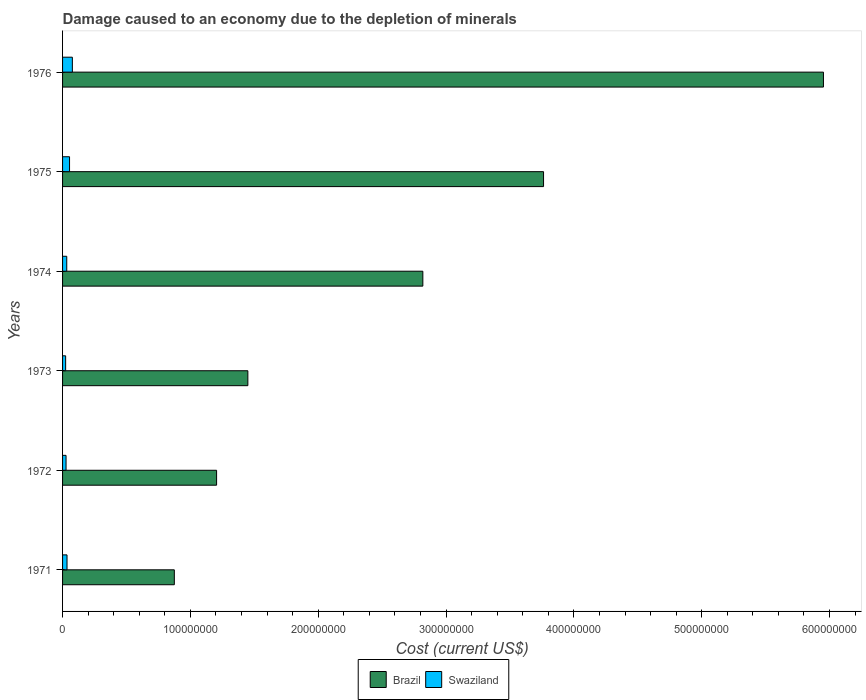How many different coloured bars are there?
Give a very brief answer. 2. Are the number of bars per tick equal to the number of legend labels?
Provide a succinct answer. Yes. What is the label of the 5th group of bars from the top?
Your response must be concise. 1972. In how many cases, is the number of bars for a given year not equal to the number of legend labels?
Provide a succinct answer. 0. What is the cost of damage caused due to the depletion of minerals in Brazil in 1973?
Keep it short and to the point. 1.45e+08. Across all years, what is the maximum cost of damage caused due to the depletion of minerals in Swaziland?
Your response must be concise. 7.66e+06. Across all years, what is the minimum cost of damage caused due to the depletion of minerals in Brazil?
Give a very brief answer. 8.74e+07. In which year was the cost of damage caused due to the depletion of minerals in Swaziland maximum?
Your response must be concise. 1976. What is the total cost of damage caused due to the depletion of minerals in Brazil in the graph?
Give a very brief answer. 1.61e+09. What is the difference between the cost of damage caused due to the depletion of minerals in Swaziland in 1971 and that in 1974?
Offer a very short reply. 2.11e+05. What is the difference between the cost of damage caused due to the depletion of minerals in Brazil in 1973 and the cost of damage caused due to the depletion of minerals in Swaziland in 1975?
Keep it short and to the point. 1.39e+08. What is the average cost of damage caused due to the depletion of minerals in Swaziland per year?
Keep it short and to the point. 4.17e+06. In the year 1973, what is the difference between the cost of damage caused due to the depletion of minerals in Swaziland and cost of damage caused due to the depletion of minerals in Brazil?
Offer a very short reply. -1.43e+08. What is the ratio of the cost of damage caused due to the depletion of minerals in Brazil in 1971 to that in 1975?
Keep it short and to the point. 0.23. Is the cost of damage caused due to the depletion of minerals in Swaziland in 1973 less than that in 1976?
Provide a short and direct response. Yes. Is the difference between the cost of damage caused due to the depletion of minerals in Swaziland in 1972 and 1973 greater than the difference between the cost of damage caused due to the depletion of minerals in Brazil in 1972 and 1973?
Keep it short and to the point. Yes. What is the difference between the highest and the second highest cost of damage caused due to the depletion of minerals in Swaziland?
Provide a succinct answer. 2.19e+06. What is the difference between the highest and the lowest cost of damage caused due to the depletion of minerals in Brazil?
Provide a succinct answer. 5.08e+08. In how many years, is the cost of damage caused due to the depletion of minerals in Brazil greater than the average cost of damage caused due to the depletion of minerals in Brazil taken over all years?
Your answer should be compact. 3. What does the 2nd bar from the top in 1971 represents?
Your answer should be compact. Brazil. What does the 1st bar from the bottom in 1974 represents?
Your answer should be compact. Brazil. How many bars are there?
Ensure brevity in your answer.  12. How many years are there in the graph?
Your response must be concise. 6. What is the difference between two consecutive major ticks on the X-axis?
Provide a succinct answer. 1.00e+08. Does the graph contain grids?
Ensure brevity in your answer.  No. How many legend labels are there?
Give a very brief answer. 2. What is the title of the graph?
Keep it short and to the point. Damage caused to an economy due to the depletion of minerals. What is the label or title of the X-axis?
Provide a succinct answer. Cost (current US$). What is the Cost (current US$) of Brazil in 1971?
Your answer should be very brief. 8.74e+07. What is the Cost (current US$) of Swaziland in 1971?
Your answer should be very brief. 3.48e+06. What is the Cost (current US$) of Brazil in 1972?
Provide a short and direct response. 1.20e+08. What is the Cost (current US$) of Swaziland in 1972?
Your answer should be compact. 2.73e+06. What is the Cost (current US$) of Brazil in 1973?
Your answer should be compact. 1.45e+08. What is the Cost (current US$) of Swaziland in 1973?
Your answer should be very brief. 2.41e+06. What is the Cost (current US$) in Brazil in 1974?
Ensure brevity in your answer.  2.82e+08. What is the Cost (current US$) in Swaziland in 1974?
Your answer should be very brief. 3.27e+06. What is the Cost (current US$) of Brazil in 1975?
Your response must be concise. 3.76e+08. What is the Cost (current US$) in Swaziland in 1975?
Give a very brief answer. 5.46e+06. What is the Cost (current US$) in Brazil in 1976?
Provide a short and direct response. 5.95e+08. What is the Cost (current US$) in Swaziland in 1976?
Your answer should be compact. 7.66e+06. Across all years, what is the maximum Cost (current US$) of Brazil?
Make the answer very short. 5.95e+08. Across all years, what is the maximum Cost (current US$) of Swaziland?
Make the answer very short. 7.66e+06. Across all years, what is the minimum Cost (current US$) of Brazil?
Offer a terse response. 8.74e+07. Across all years, what is the minimum Cost (current US$) of Swaziland?
Keep it short and to the point. 2.41e+06. What is the total Cost (current US$) of Brazil in the graph?
Give a very brief answer. 1.61e+09. What is the total Cost (current US$) of Swaziland in the graph?
Offer a very short reply. 2.50e+07. What is the difference between the Cost (current US$) of Brazil in 1971 and that in 1972?
Offer a terse response. -3.31e+07. What is the difference between the Cost (current US$) in Swaziland in 1971 and that in 1972?
Provide a succinct answer. 7.55e+05. What is the difference between the Cost (current US$) of Brazil in 1971 and that in 1973?
Keep it short and to the point. -5.75e+07. What is the difference between the Cost (current US$) in Swaziland in 1971 and that in 1973?
Your response must be concise. 1.07e+06. What is the difference between the Cost (current US$) of Brazil in 1971 and that in 1974?
Give a very brief answer. -1.94e+08. What is the difference between the Cost (current US$) of Swaziland in 1971 and that in 1974?
Give a very brief answer. 2.11e+05. What is the difference between the Cost (current US$) in Brazil in 1971 and that in 1975?
Provide a short and direct response. -2.89e+08. What is the difference between the Cost (current US$) in Swaziland in 1971 and that in 1975?
Your answer should be compact. -1.98e+06. What is the difference between the Cost (current US$) of Brazil in 1971 and that in 1976?
Your answer should be very brief. -5.08e+08. What is the difference between the Cost (current US$) of Swaziland in 1971 and that in 1976?
Ensure brevity in your answer.  -4.17e+06. What is the difference between the Cost (current US$) of Brazil in 1972 and that in 1973?
Keep it short and to the point. -2.45e+07. What is the difference between the Cost (current US$) of Swaziland in 1972 and that in 1973?
Keep it short and to the point. 3.19e+05. What is the difference between the Cost (current US$) of Brazil in 1972 and that in 1974?
Ensure brevity in your answer.  -1.61e+08. What is the difference between the Cost (current US$) in Swaziland in 1972 and that in 1974?
Provide a succinct answer. -5.44e+05. What is the difference between the Cost (current US$) in Brazil in 1972 and that in 1975?
Your answer should be very brief. -2.56e+08. What is the difference between the Cost (current US$) of Swaziland in 1972 and that in 1975?
Provide a short and direct response. -2.74e+06. What is the difference between the Cost (current US$) of Brazil in 1972 and that in 1976?
Make the answer very short. -4.75e+08. What is the difference between the Cost (current US$) in Swaziland in 1972 and that in 1976?
Give a very brief answer. -4.93e+06. What is the difference between the Cost (current US$) in Brazil in 1973 and that in 1974?
Make the answer very short. -1.37e+08. What is the difference between the Cost (current US$) of Swaziland in 1973 and that in 1974?
Your response must be concise. -8.63e+05. What is the difference between the Cost (current US$) of Brazil in 1973 and that in 1975?
Your answer should be very brief. -2.31e+08. What is the difference between the Cost (current US$) in Swaziland in 1973 and that in 1975?
Your response must be concise. -3.05e+06. What is the difference between the Cost (current US$) in Brazil in 1973 and that in 1976?
Offer a terse response. -4.50e+08. What is the difference between the Cost (current US$) of Swaziland in 1973 and that in 1976?
Your answer should be compact. -5.25e+06. What is the difference between the Cost (current US$) in Brazil in 1974 and that in 1975?
Offer a very short reply. -9.44e+07. What is the difference between the Cost (current US$) in Swaziland in 1974 and that in 1975?
Your answer should be compact. -2.19e+06. What is the difference between the Cost (current US$) in Brazil in 1974 and that in 1976?
Your answer should be compact. -3.13e+08. What is the difference between the Cost (current US$) of Swaziland in 1974 and that in 1976?
Offer a terse response. -4.38e+06. What is the difference between the Cost (current US$) in Brazil in 1975 and that in 1976?
Your answer should be very brief. -2.19e+08. What is the difference between the Cost (current US$) of Swaziland in 1975 and that in 1976?
Give a very brief answer. -2.19e+06. What is the difference between the Cost (current US$) in Brazil in 1971 and the Cost (current US$) in Swaziland in 1972?
Provide a short and direct response. 8.47e+07. What is the difference between the Cost (current US$) of Brazil in 1971 and the Cost (current US$) of Swaziland in 1973?
Ensure brevity in your answer.  8.50e+07. What is the difference between the Cost (current US$) of Brazil in 1971 and the Cost (current US$) of Swaziland in 1974?
Provide a short and direct response. 8.42e+07. What is the difference between the Cost (current US$) in Brazil in 1971 and the Cost (current US$) in Swaziland in 1975?
Keep it short and to the point. 8.20e+07. What is the difference between the Cost (current US$) of Brazil in 1971 and the Cost (current US$) of Swaziland in 1976?
Offer a terse response. 7.98e+07. What is the difference between the Cost (current US$) of Brazil in 1972 and the Cost (current US$) of Swaziland in 1973?
Make the answer very short. 1.18e+08. What is the difference between the Cost (current US$) of Brazil in 1972 and the Cost (current US$) of Swaziland in 1974?
Give a very brief answer. 1.17e+08. What is the difference between the Cost (current US$) of Brazil in 1972 and the Cost (current US$) of Swaziland in 1975?
Keep it short and to the point. 1.15e+08. What is the difference between the Cost (current US$) in Brazil in 1972 and the Cost (current US$) in Swaziland in 1976?
Offer a very short reply. 1.13e+08. What is the difference between the Cost (current US$) of Brazil in 1973 and the Cost (current US$) of Swaziland in 1974?
Provide a short and direct response. 1.42e+08. What is the difference between the Cost (current US$) of Brazil in 1973 and the Cost (current US$) of Swaziland in 1975?
Offer a terse response. 1.39e+08. What is the difference between the Cost (current US$) of Brazil in 1973 and the Cost (current US$) of Swaziland in 1976?
Provide a short and direct response. 1.37e+08. What is the difference between the Cost (current US$) of Brazil in 1974 and the Cost (current US$) of Swaziland in 1975?
Your response must be concise. 2.76e+08. What is the difference between the Cost (current US$) in Brazil in 1974 and the Cost (current US$) in Swaziland in 1976?
Provide a short and direct response. 2.74e+08. What is the difference between the Cost (current US$) in Brazil in 1975 and the Cost (current US$) in Swaziland in 1976?
Offer a terse response. 3.69e+08. What is the average Cost (current US$) of Brazil per year?
Keep it short and to the point. 2.68e+08. What is the average Cost (current US$) in Swaziland per year?
Ensure brevity in your answer.  4.17e+06. In the year 1971, what is the difference between the Cost (current US$) of Brazil and Cost (current US$) of Swaziland?
Provide a short and direct response. 8.40e+07. In the year 1972, what is the difference between the Cost (current US$) of Brazil and Cost (current US$) of Swaziland?
Your answer should be very brief. 1.18e+08. In the year 1973, what is the difference between the Cost (current US$) of Brazil and Cost (current US$) of Swaziland?
Your answer should be very brief. 1.43e+08. In the year 1974, what is the difference between the Cost (current US$) in Brazil and Cost (current US$) in Swaziland?
Give a very brief answer. 2.79e+08. In the year 1975, what is the difference between the Cost (current US$) of Brazil and Cost (current US$) of Swaziland?
Keep it short and to the point. 3.71e+08. In the year 1976, what is the difference between the Cost (current US$) of Brazil and Cost (current US$) of Swaziland?
Your answer should be compact. 5.88e+08. What is the ratio of the Cost (current US$) of Brazil in 1971 to that in 1972?
Provide a short and direct response. 0.73. What is the ratio of the Cost (current US$) in Swaziland in 1971 to that in 1972?
Your answer should be very brief. 1.28. What is the ratio of the Cost (current US$) in Brazil in 1971 to that in 1973?
Provide a succinct answer. 0.6. What is the ratio of the Cost (current US$) of Swaziland in 1971 to that in 1973?
Give a very brief answer. 1.45. What is the ratio of the Cost (current US$) of Brazil in 1971 to that in 1974?
Make the answer very short. 0.31. What is the ratio of the Cost (current US$) of Swaziland in 1971 to that in 1974?
Make the answer very short. 1.06. What is the ratio of the Cost (current US$) of Brazil in 1971 to that in 1975?
Your answer should be compact. 0.23. What is the ratio of the Cost (current US$) in Swaziland in 1971 to that in 1975?
Your response must be concise. 0.64. What is the ratio of the Cost (current US$) of Brazil in 1971 to that in 1976?
Offer a very short reply. 0.15. What is the ratio of the Cost (current US$) of Swaziland in 1971 to that in 1976?
Keep it short and to the point. 0.45. What is the ratio of the Cost (current US$) in Brazil in 1972 to that in 1973?
Your answer should be very brief. 0.83. What is the ratio of the Cost (current US$) of Swaziland in 1972 to that in 1973?
Give a very brief answer. 1.13. What is the ratio of the Cost (current US$) in Brazil in 1972 to that in 1974?
Offer a very short reply. 0.43. What is the ratio of the Cost (current US$) of Swaziland in 1972 to that in 1974?
Your answer should be very brief. 0.83. What is the ratio of the Cost (current US$) of Brazil in 1972 to that in 1975?
Your response must be concise. 0.32. What is the ratio of the Cost (current US$) in Swaziland in 1972 to that in 1975?
Your answer should be very brief. 0.5. What is the ratio of the Cost (current US$) in Brazil in 1972 to that in 1976?
Provide a short and direct response. 0.2. What is the ratio of the Cost (current US$) of Swaziland in 1972 to that in 1976?
Ensure brevity in your answer.  0.36. What is the ratio of the Cost (current US$) in Brazil in 1973 to that in 1974?
Provide a succinct answer. 0.51. What is the ratio of the Cost (current US$) of Swaziland in 1973 to that in 1974?
Keep it short and to the point. 0.74. What is the ratio of the Cost (current US$) of Brazil in 1973 to that in 1975?
Your answer should be compact. 0.39. What is the ratio of the Cost (current US$) of Swaziland in 1973 to that in 1975?
Offer a terse response. 0.44. What is the ratio of the Cost (current US$) in Brazil in 1973 to that in 1976?
Your answer should be compact. 0.24. What is the ratio of the Cost (current US$) of Swaziland in 1973 to that in 1976?
Keep it short and to the point. 0.31. What is the ratio of the Cost (current US$) in Brazil in 1974 to that in 1975?
Give a very brief answer. 0.75. What is the ratio of the Cost (current US$) of Swaziland in 1974 to that in 1975?
Give a very brief answer. 0.6. What is the ratio of the Cost (current US$) in Brazil in 1974 to that in 1976?
Your answer should be very brief. 0.47. What is the ratio of the Cost (current US$) in Swaziland in 1974 to that in 1976?
Provide a succinct answer. 0.43. What is the ratio of the Cost (current US$) of Brazil in 1975 to that in 1976?
Make the answer very short. 0.63. What is the ratio of the Cost (current US$) of Swaziland in 1975 to that in 1976?
Provide a short and direct response. 0.71. What is the difference between the highest and the second highest Cost (current US$) in Brazil?
Your answer should be compact. 2.19e+08. What is the difference between the highest and the second highest Cost (current US$) of Swaziland?
Give a very brief answer. 2.19e+06. What is the difference between the highest and the lowest Cost (current US$) in Brazil?
Your answer should be very brief. 5.08e+08. What is the difference between the highest and the lowest Cost (current US$) in Swaziland?
Provide a succinct answer. 5.25e+06. 